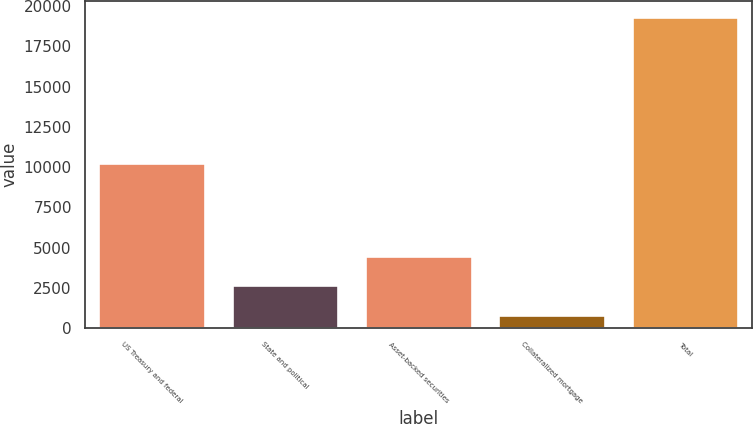<chart> <loc_0><loc_0><loc_500><loc_500><bar_chart><fcel>US Treasury and federal<fcel>State and political<fcel>Asset-backed securities<fcel>Collateralized mortgage<fcel>Total<nl><fcel>10248<fcel>2649.3<fcel>4503.6<fcel>795<fcel>19338<nl></chart> 